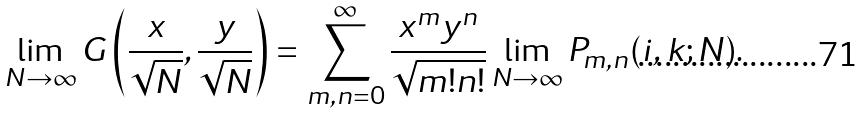<formula> <loc_0><loc_0><loc_500><loc_500>\lim _ { N \rightarrow \infty } G \left ( \frac { x } { \sqrt { N } } , \frac { y } { \sqrt { N } } \right ) = \sum _ { m , n = 0 } ^ { \infty } \frac { x ^ { m } y ^ { n } } { \sqrt { m ! n ! } } \lim _ { N \rightarrow \infty } P _ { m , n } ( i , k ; N ) .</formula> 